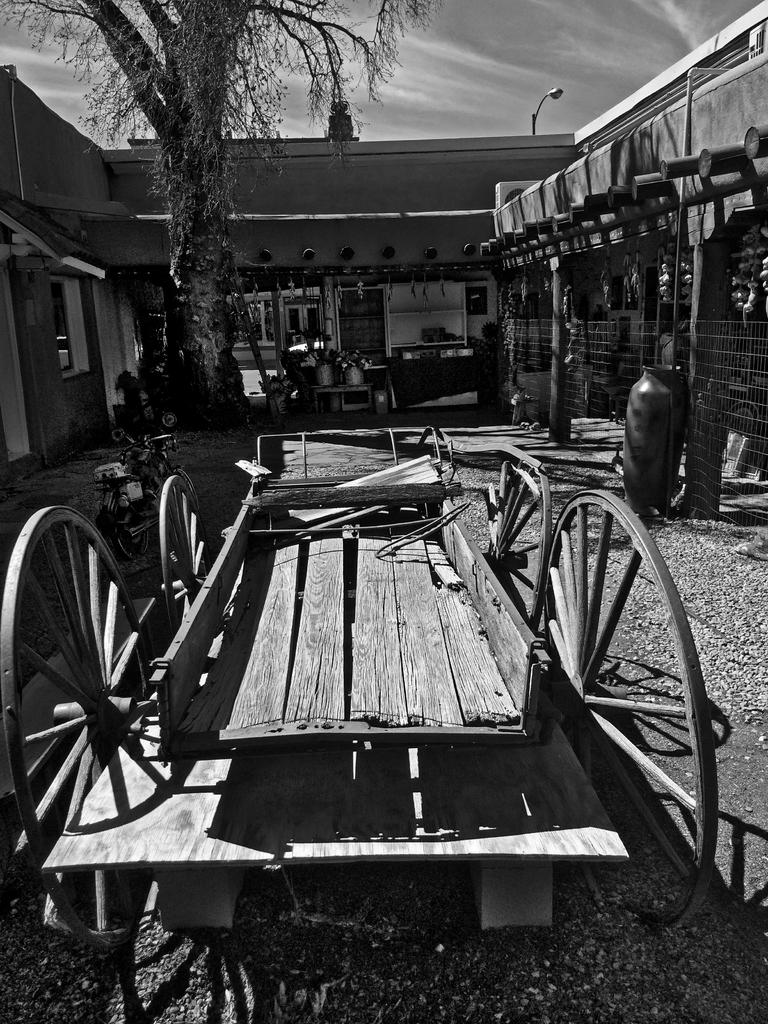What type of vehicle is in the image? There is a bullock cart in the image. Where is the bullock cart located in the image? The bullock cart is in the front of the image. What can be seen in the background of the image? There is a building in the background of the image. What type of vegetation is on the right side of the image? There is a tree on the right side of the image. What type of wine is being served at the camp in the image? There is no camp or wine present in the image; it features a bullock cart, a building in the background, and a tree on the right side. What songs are being sung by the people in the image? There are no people or songs present in the image; it features a bullock cart, a building in the background, and a tree on the right side. 